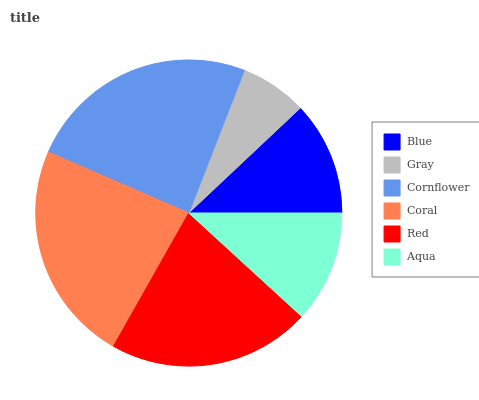Is Gray the minimum?
Answer yes or no. Yes. Is Cornflower the maximum?
Answer yes or no. Yes. Is Cornflower the minimum?
Answer yes or no. No. Is Gray the maximum?
Answer yes or no. No. Is Cornflower greater than Gray?
Answer yes or no. Yes. Is Gray less than Cornflower?
Answer yes or no. Yes. Is Gray greater than Cornflower?
Answer yes or no. No. Is Cornflower less than Gray?
Answer yes or no. No. Is Red the high median?
Answer yes or no. Yes. Is Blue the low median?
Answer yes or no. Yes. Is Aqua the high median?
Answer yes or no. No. Is Cornflower the low median?
Answer yes or no. No. 